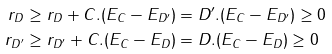<formula> <loc_0><loc_0><loc_500><loc_500>r _ { D } & \geq r _ { D } + C . ( E _ { C } - E _ { D ^ { \prime } } ) = D ^ { \prime } . ( E _ { C } - E _ { D ^ { \prime } } ) \geq 0 \\ r _ { D ^ { \prime } } & \geq r _ { D ^ { \prime } } + C . ( E _ { C } - E _ { D } ) = D . ( E _ { C } - E _ { D } ) \geq 0</formula> 